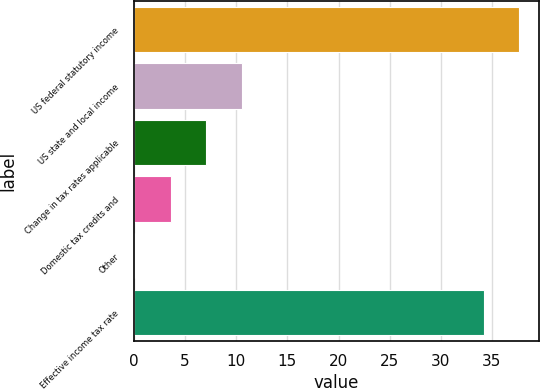Convert chart. <chart><loc_0><loc_0><loc_500><loc_500><bar_chart><fcel>US federal statutory income<fcel>US state and local income<fcel>Change in tax rates applicable<fcel>Domestic tax credits and<fcel>Other<fcel>Effective income tax rate<nl><fcel>37.68<fcel>10.57<fcel>7.08<fcel>3.59<fcel>0.1<fcel>34.19<nl></chart> 